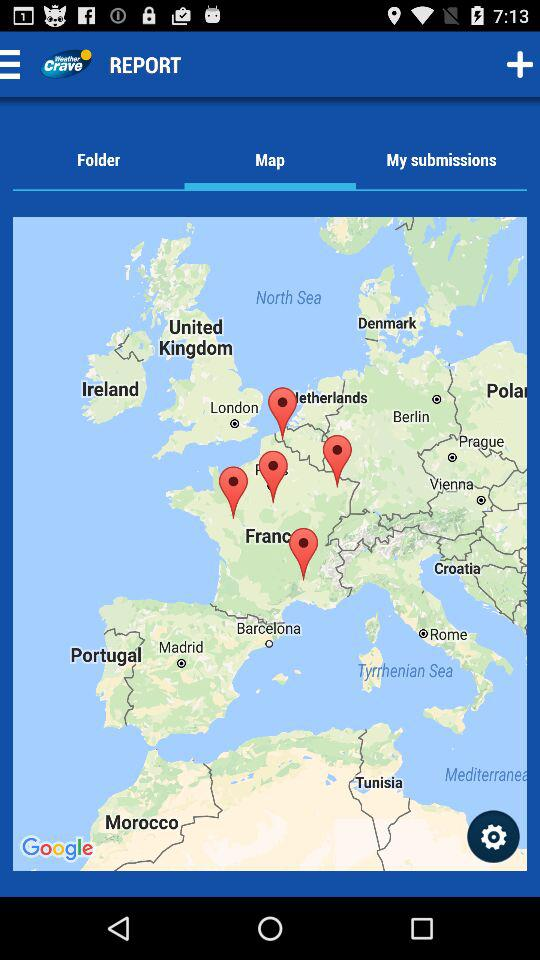Which is the selected tab? The selected tab is "Map". 